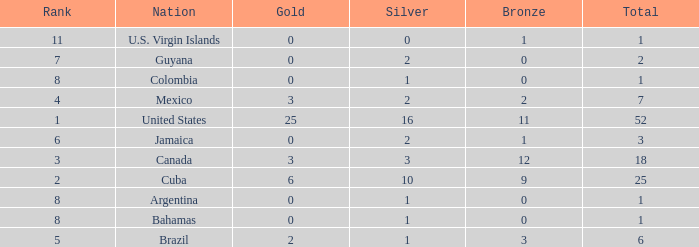What is the fewest number of silver medals a nation who ranked below 8 received? 0.0. 